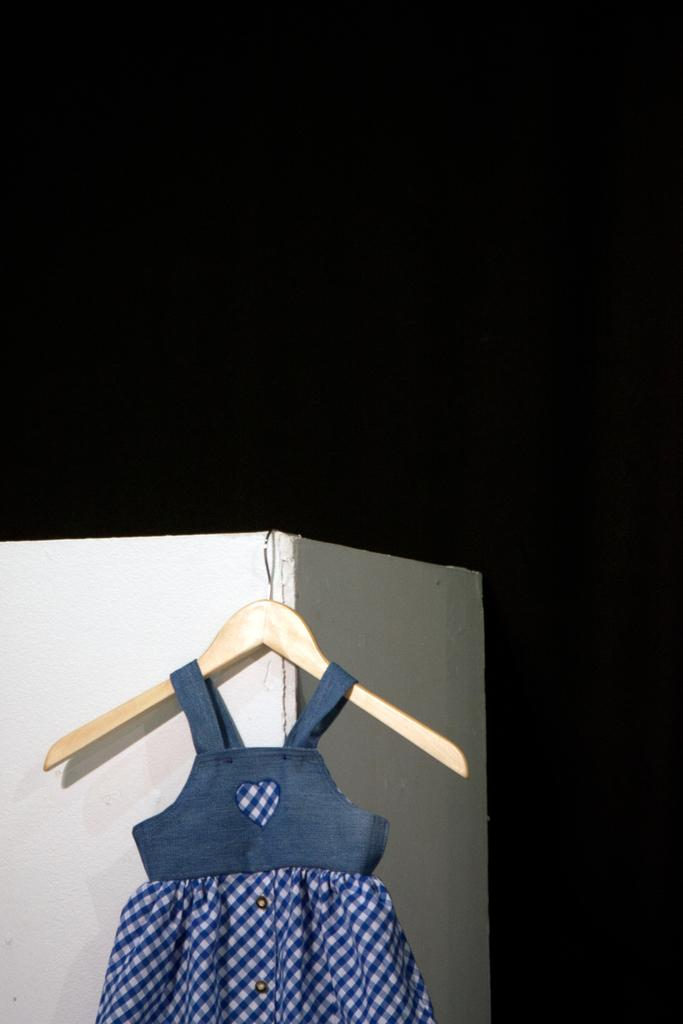What color is the frock in the image? The frock in the image is blue. How is the frock positioned in the image? The frock is on a hanger. What is the color of the pillar in the image? The pillar in the image is cream-colored. What color is the background of the image? The background of the image is black. What type of tin can be seen on the elbow of the person in the image? There is no person or elbow present in the image; it only features a blue frock on a hanger and a cream-colored pillar against a black background. 